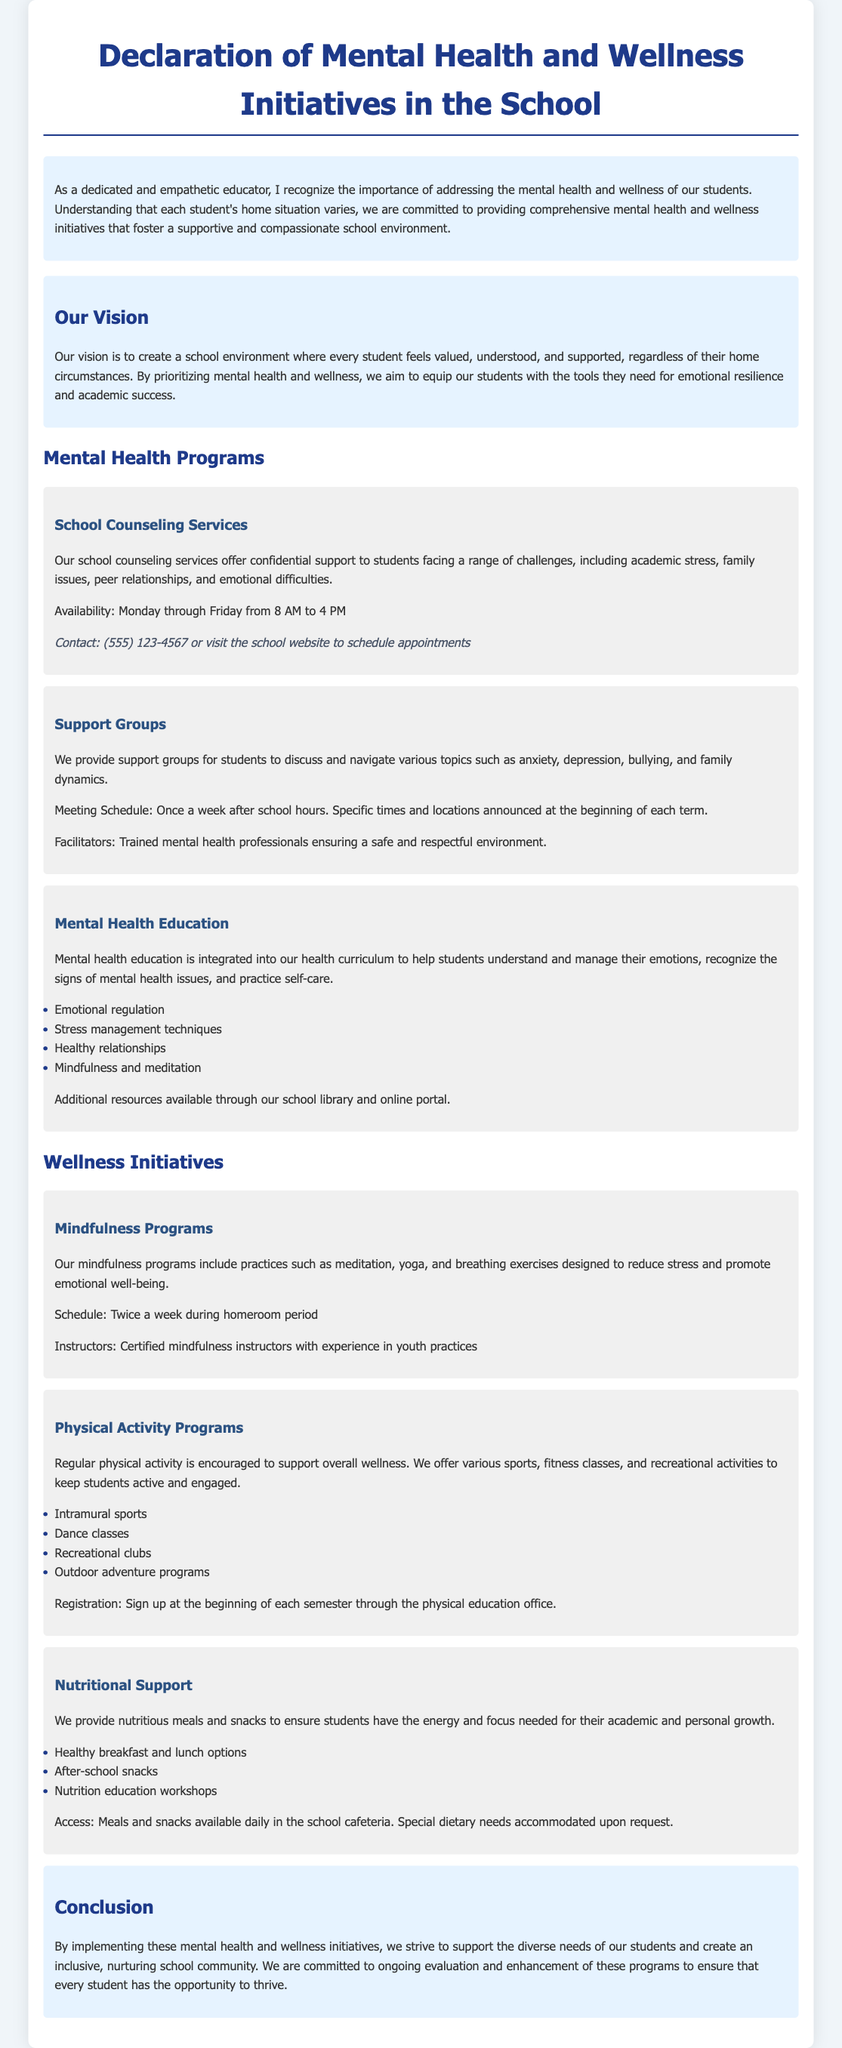What are the school counseling service hours? The document specifies that the counseling services are available from Monday through Friday from 8 AM to 4 PM.
Answer: Monday through Friday from 8 AM to 4 PM What types of support groups are offered? The support groups cover topics such as anxiety, depression, bullying, and family dynamics.
Answer: Anxiety, depression, bullying, family dynamics How often are mindfulness programs scheduled? The document states that mindfulness programs take place twice a week during homeroom period.
Answer: Twice a week Who facilitates the support groups? It mentions that trained mental health professionals ensure a safe and respectful environment for the support groups.
Answer: Trained mental health professionals What meals are provided to students? The document lists healthy breakfast and lunch options, after-school snacks, and nutrition education workshops.
Answer: Healthy breakfast and lunch options, after-school snacks What is the main vision of the mental health initiatives? The vision is to create a school environment where every student feels valued, understood, and supported.
Answer: Every student feels valued, understood, and supported What types of physical activity programs are available? The document includes intramural sports, dance classes, recreational clubs, and outdoor adventure programs.
Answer: Intramural sports, dance classes, recreational clubs, outdoor adventure programs When can students register for physical activity programs? Registration is at the beginning of each semester through the physical education office.
Answer: Beginning of each semester 